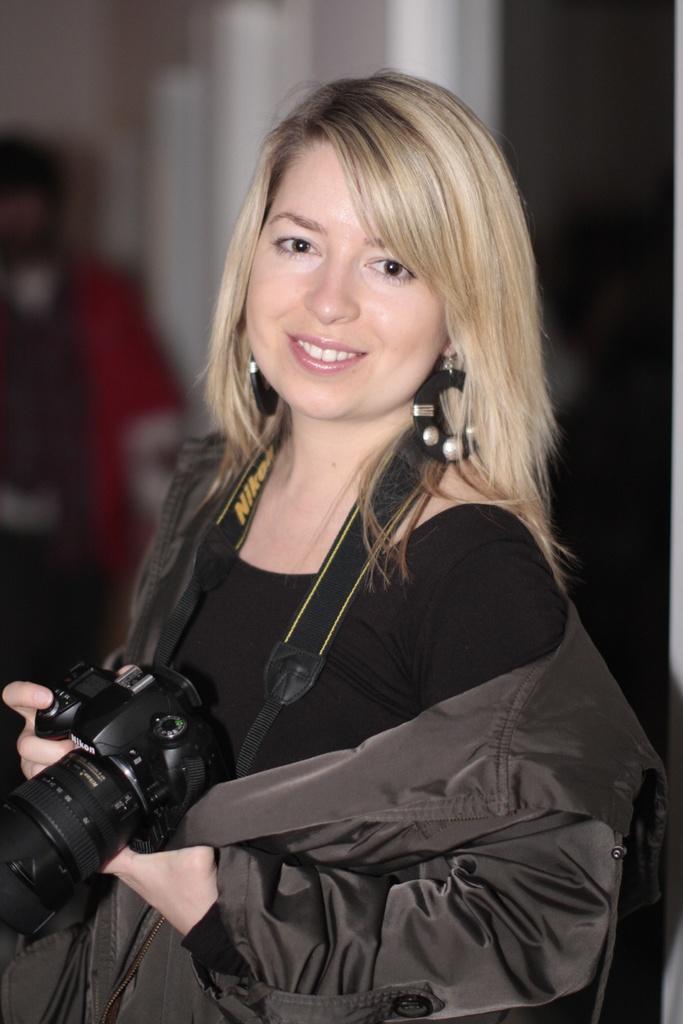Could you give a brief overview of what you see in this image? A girl with black jacket is standing and holding a camera in her hand. She is smiling. 